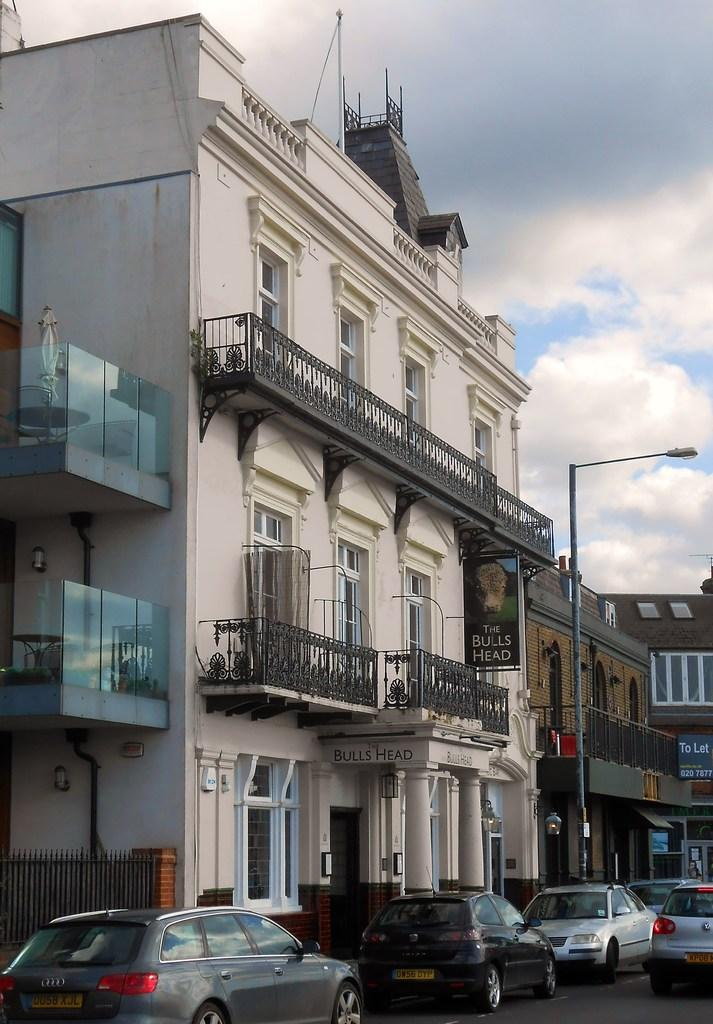What is the color of the building in the image? The building is white in color. What can be seen near the building? There are cars parked on the road near the building. How would you describe the sky in the image? The sky is cloudy. How many cows are grazing in front of the building in the image? There are no cows present in the image; the focus is on the white building and parked cars. 